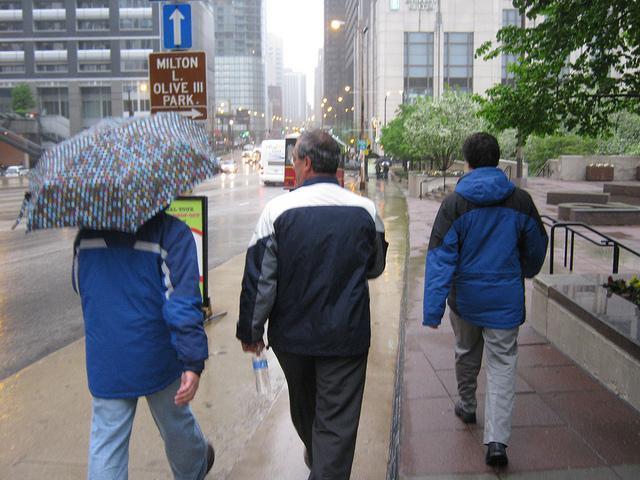How many people are seen?
Give a very brief answer. 3. How many people are wearing red?
Give a very brief answer. 0. How many cones are there?
Give a very brief answer. 0. How many people are there?
Give a very brief answer. 3. How many brown chairs are in the picture?
Give a very brief answer. 0. 